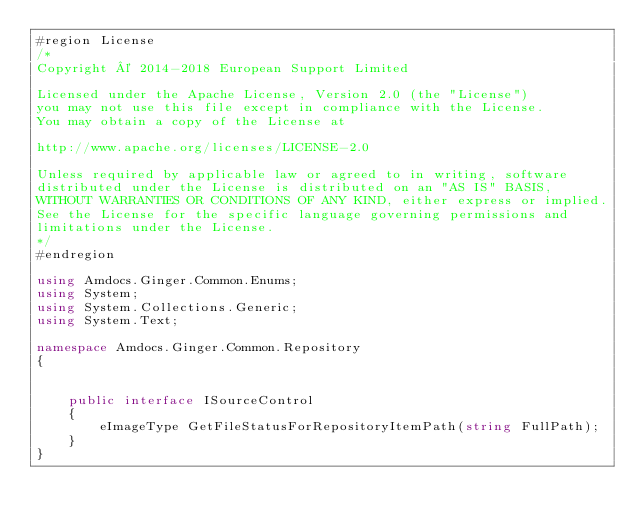<code> <loc_0><loc_0><loc_500><loc_500><_C#_>#region License
/*
Copyright © 2014-2018 European Support Limited

Licensed under the Apache License, Version 2.0 (the "License")
you may not use this file except in compliance with the License.
You may obtain a copy of the License at 

http://www.apache.org/licenses/LICENSE-2.0 

Unless required by applicable law or agreed to in writing, software
distributed under the License is distributed on an "AS IS" BASIS, 
WITHOUT WARRANTIES OR CONDITIONS OF ANY KIND, either express or implied. 
See the License for the specific language governing permissions and 
limitations under the License. 
*/
#endregion

using Amdocs.Ginger.Common.Enums;
using System;
using System.Collections.Generic;
using System.Text;

namespace Amdocs.Ginger.Common.Repository
{

    
    public interface ISourceControl
    {
        eImageType GetFileStatusForRepositoryItemPath(string FullPath);
    }
}
</code> 